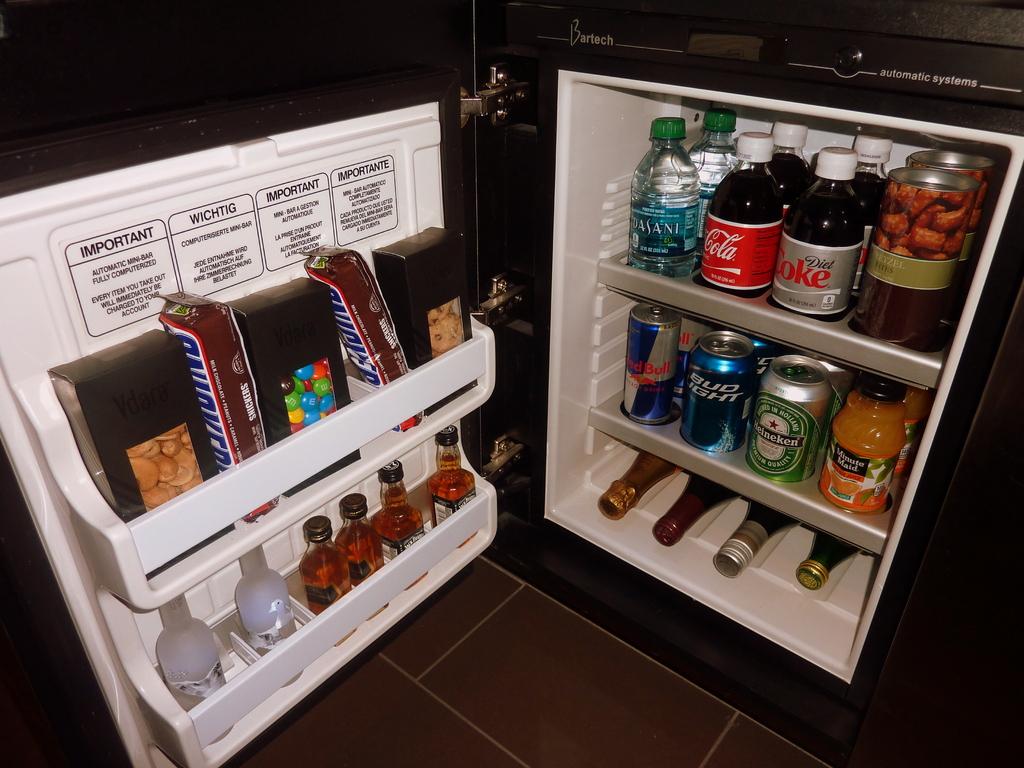What candy bar is on door?
Give a very brief answer. Snickers. What brand of cola is in the top center rack of the fridge?
Give a very brief answer. Coca cola. 